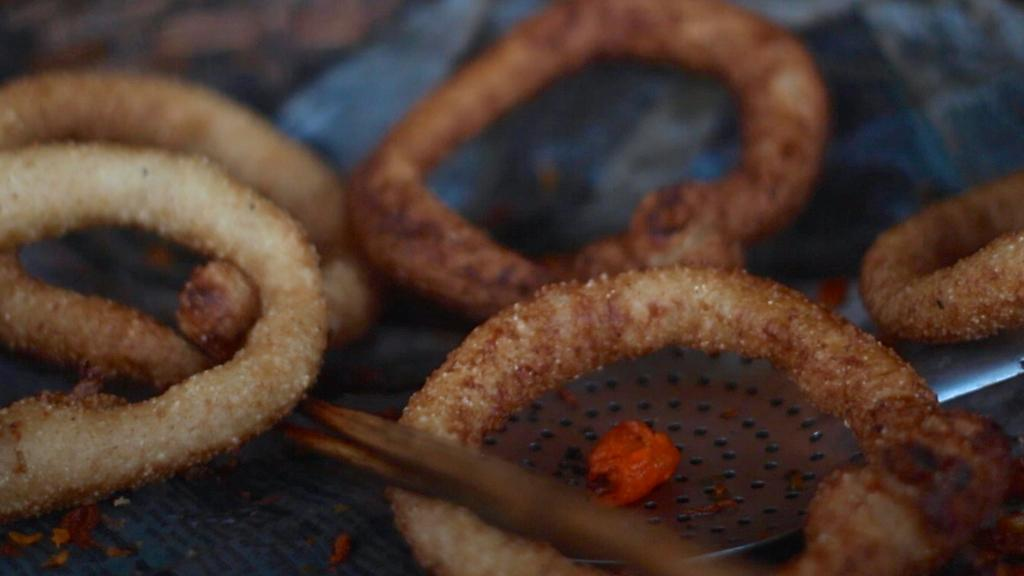What type of items can be seen in the image? There are eatables in the image. What utensil is present in the image? There is a spoon in the image. Can you describe the background of the image? The background of the image is blurred, and there is an object in blue color. What type of celery is being used as a decoration in the image? There is no celery present in the image. Can you tell me how many bones are visible in the image? There are no bones visible in the image. 